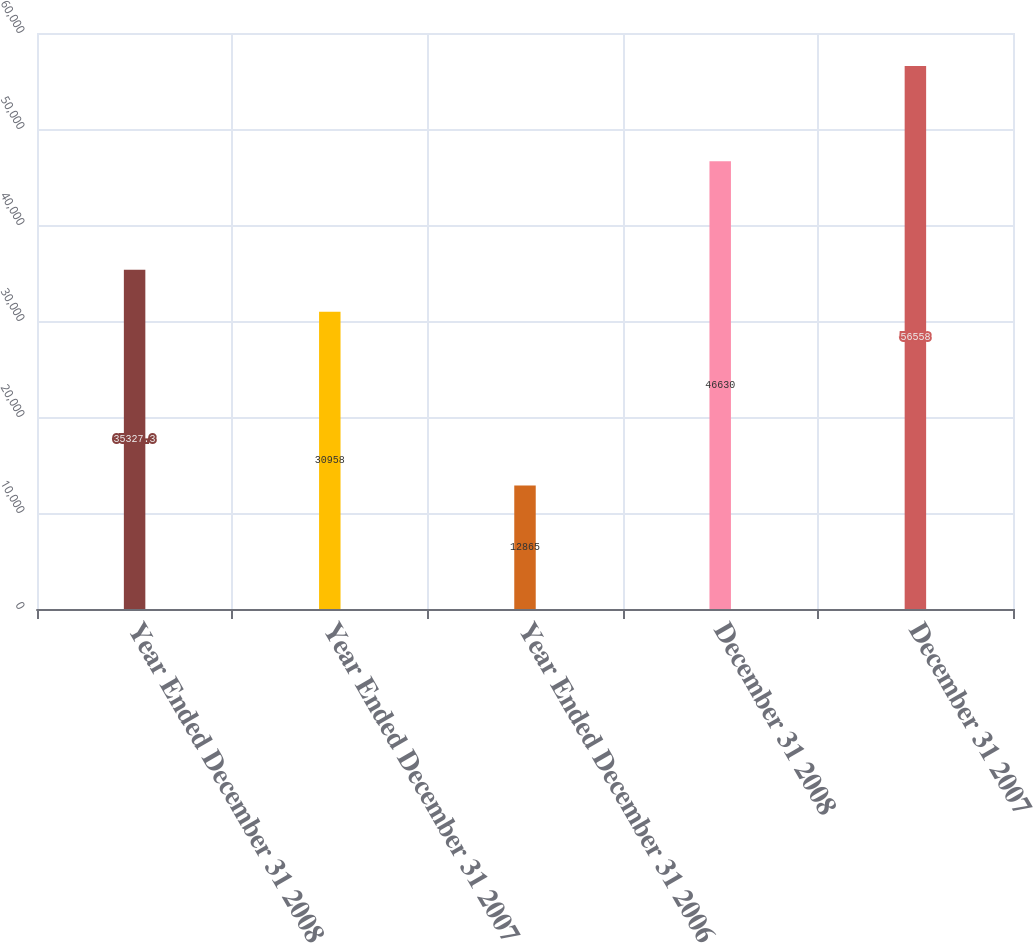Convert chart to OTSL. <chart><loc_0><loc_0><loc_500><loc_500><bar_chart><fcel>Year Ended December 31 2008<fcel>Year Ended December 31 2007<fcel>Year Ended December 31 2006<fcel>December 31 2008<fcel>December 31 2007<nl><fcel>35327.3<fcel>30958<fcel>12865<fcel>46630<fcel>56558<nl></chart> 